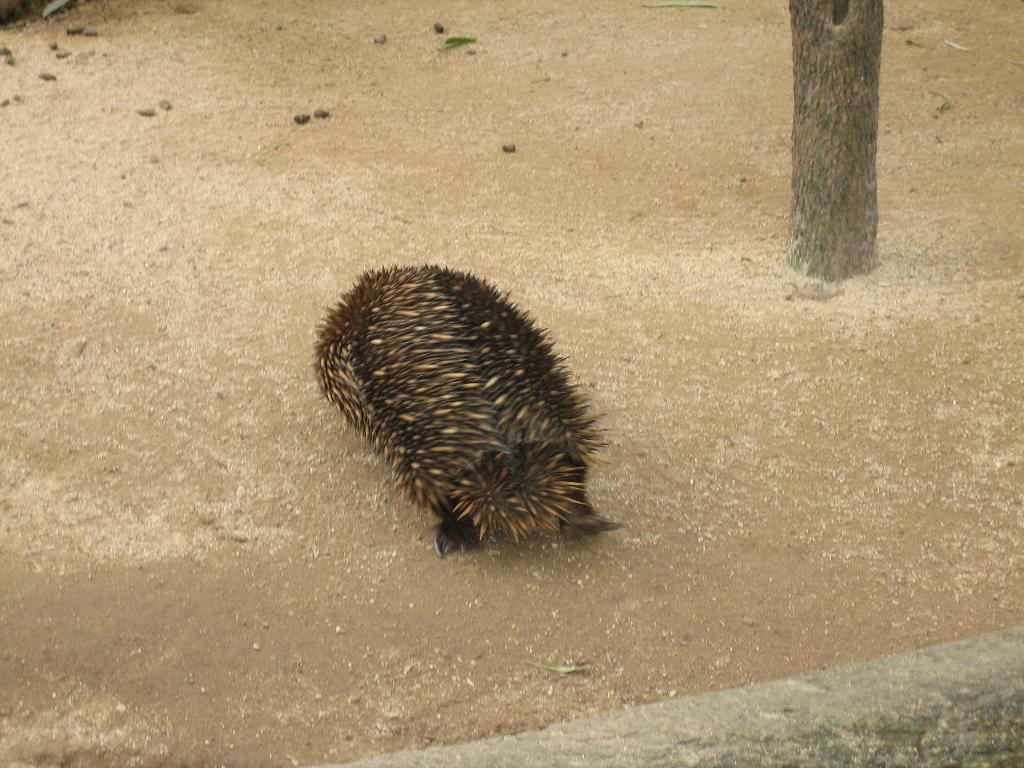What type of animal can be seen in the image? There is an animal in the image, but its specific type cannot be determined from the provided facts. What color is the animal in the image? The animal is black in color. What is the surface visible in the image? There is a ground visible in the image. What type of vegetation is on the right side of the image? There is a tree on the right side of the image. What type of structure is at the bottom of the image? There is a wall at the bottom of the image. Can you see any cobwebs in the image? There is no mention of cobwebs in the provided facts, so it cannot be determined if any are present in the image. Can the animal in the image touch the tree? The provided facts do not give any information about the animal's ability to move or interact with the tree, so it cannot be determined if it can touch the tree. 